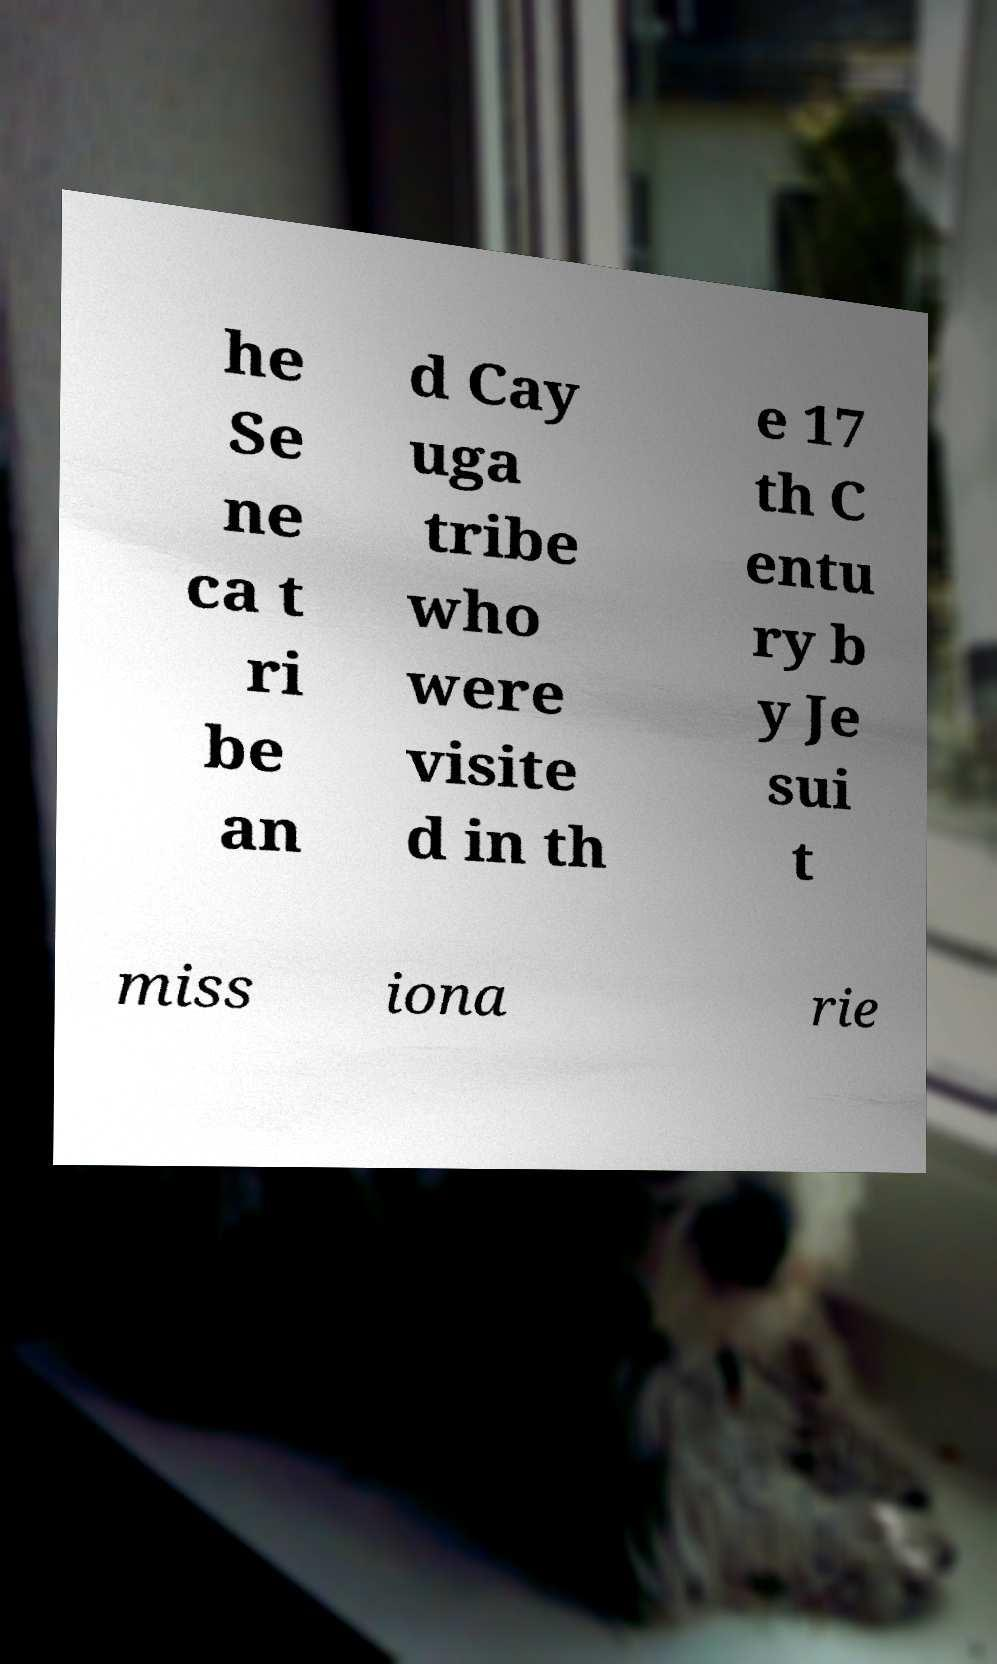Can you accurately transcribe the text from the provided image for me? he Se ne ca t ri be an d Cay uga tribe who were visite d in th e 17 th C entu ry b y Je sui t miss iona rie 